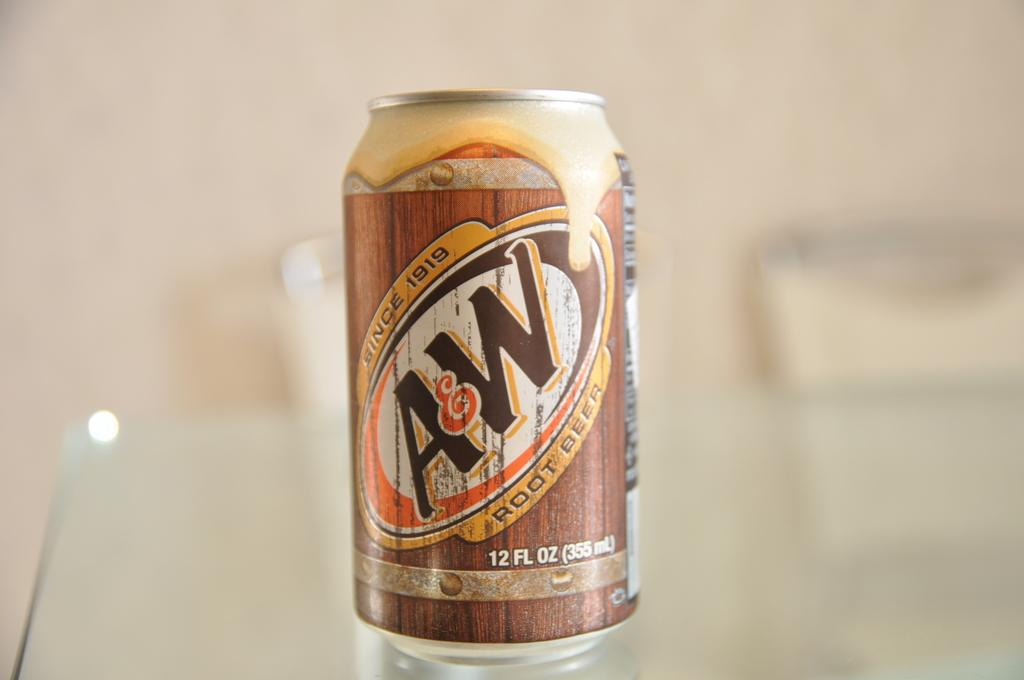<image>
Create a compact narrative representing the image presented. A can of A and W root beer. 